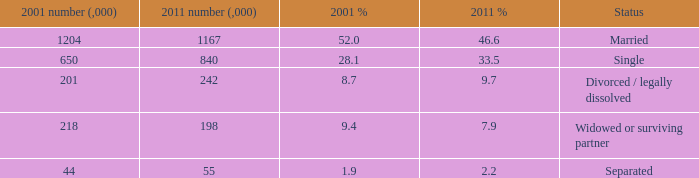What si the 2011 number (,000) when 2001 % is 28.1? 840.0. 